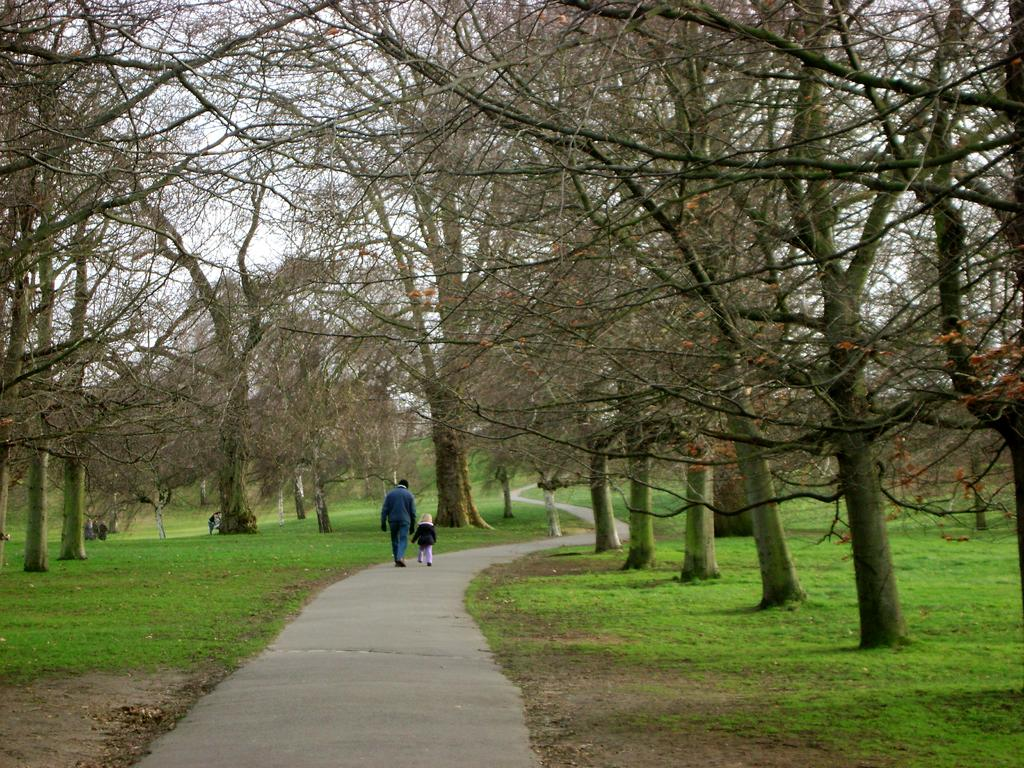Who is present in the image? There is a person and a child in the image. Where are the person and the child located? Both the person and the child are on the road. What can be seen in the background of the image? There is grass, trees, and the sky visible in the background of the image. What type of operation is being performed on the bucket in the image? There is no bucket present in the image, so no operation can be observed. 